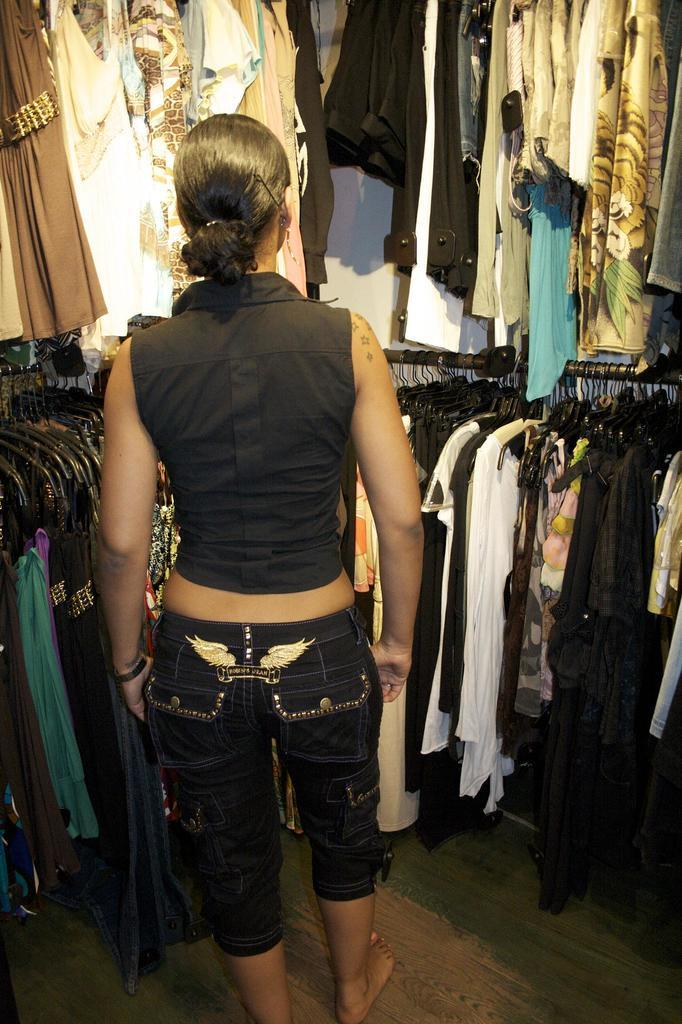Where was the image taken? The image was taken inside a closet. What can be found in the closet? There are many clothes and hangers in the closet. Is there anyone in the image? Yes, there is a person in the image. What color clothes is the person wearing? The person is wearing black clothes. What type of ticket is visible in the image? There is no ticket present in the image. What frame is the person standing in front of in the image? There is no frame present in the image. 